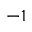Convert formula to latex. <formula><loc_0><loc_0><loc_500><loc_500>^ { - 1 }</formula> 